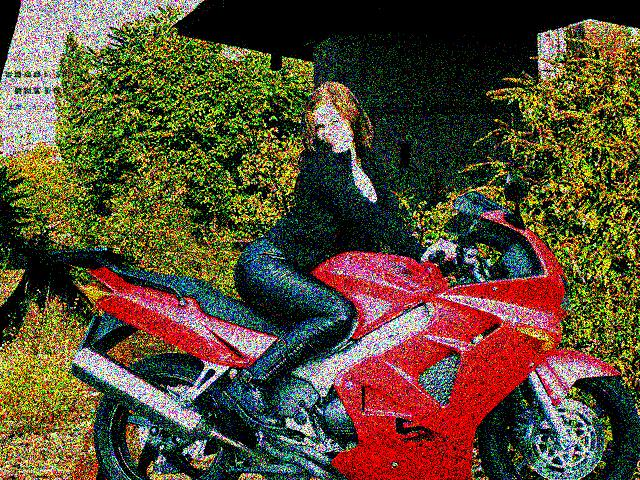Can you describe the setting in which the motorcycle and person are found? Certainly, the motorcycle with the individual seated on it seems to be parked in an area surrounded by greenery, indicating a suburban setting or the outskirts of a rural area. There's a structure partially visible in the background that could be a shed or carport, and the relaxed posture of the person suggests it might be a private space or a leisure area. 